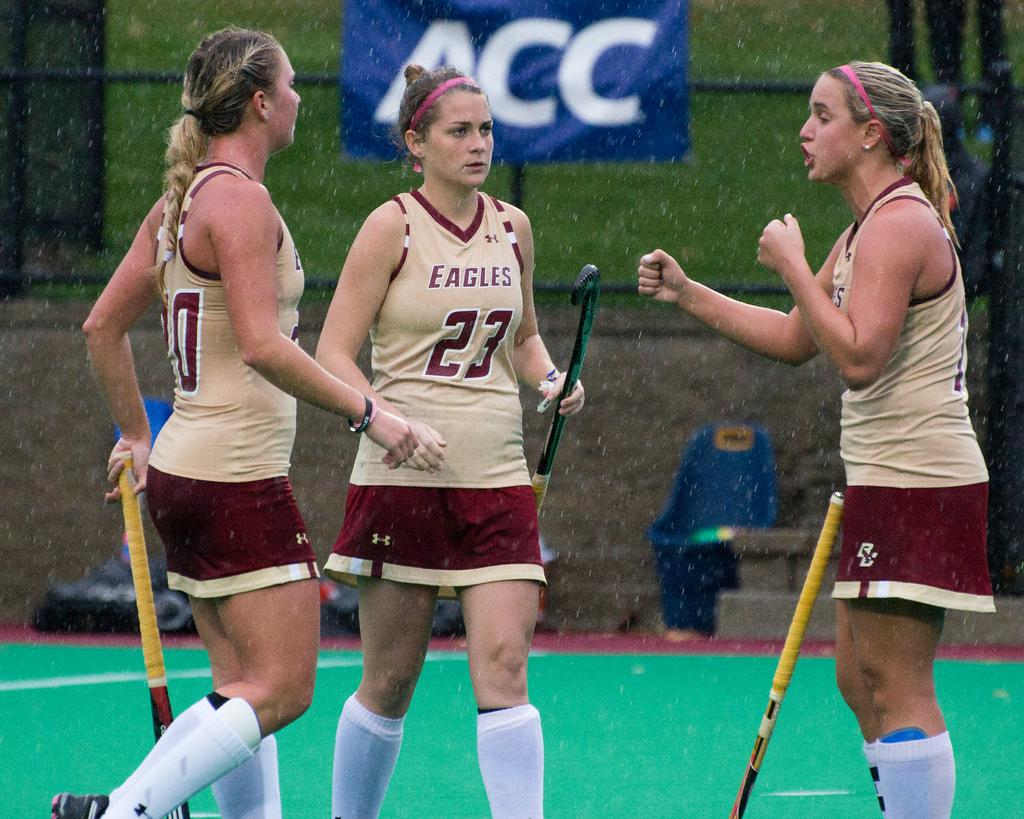How many women are present in the image? There are three women in the image. Can you describe the position of one of the women? One of the women is standing on the right side. What is the woman on the right side doing? The woman on the right side is talking. What type of property is being discussed by the woman on the right side? There is no indication in the image of any property being discussed. 